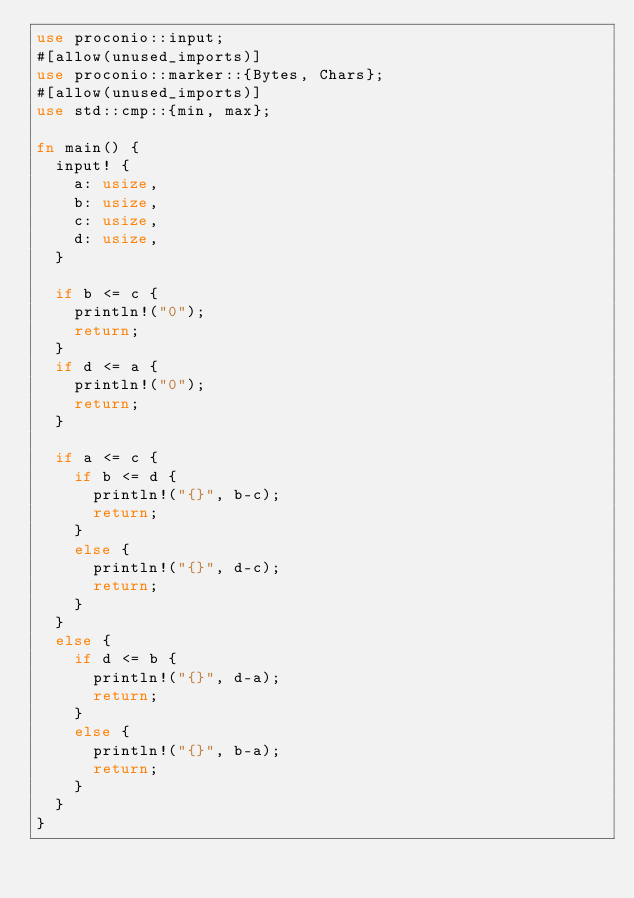Convert code to text. <code><loc_0><loc_0><loc_500><loc_500><_Rust_>use proconio::input;
#[allow(unused_imports)]
use proconio::marker::{Bytes, Chars};
#[allow(unused_imports)]
use std::cmp::{min, max};

fn main() {
	input! {
		a: usize,
		b: usize,
		c: usize,
		d: usize,
	}

	if b <= c {
		println!("0");
		return;
	}
	if d <= a {
		println!("0");
		return;
	}

	if a <= c {
		if b <= d {
			println!("{}", b-c);
			return;				
		}
		else {
			println!("{}", d-c);
			return;				
		}
	}
	else {
		if d <= b {
			println!("{}", d-a);
			return;				
		}
		else {
			println!("{}", b-a);
			return;				
		}
	}
}

</code> 